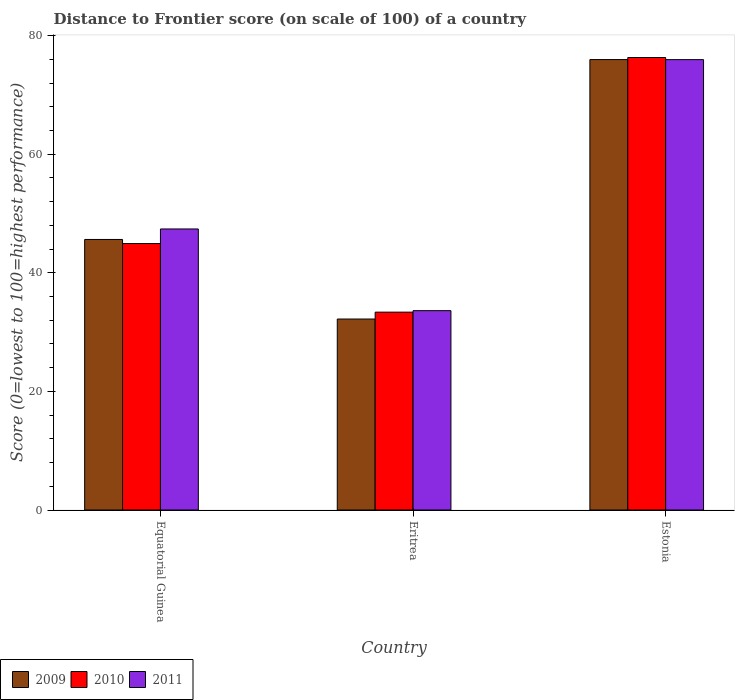How many different coloured bars are there?
Provide a short and direct response. 3. Are the number of bars per tick equal to the number of legend labels?
Make the answer very short. Yes. How many bars are there on the 2nd tick from the left?
Make the answer very short. 3. What is the label of the 2nd group of bars from the left?
Your response must be concise. Eritrea. In how many cases, is the number of bars for a given country not equal to the number of legend labels?
Your response must be concise. 0. What is the distance to frontier score of in 2009 in Estonia?
Your response must be concise. 75.97. Across all countries, what is the maximum distance to frontier score of in 2011?
Give a very brief answer. 75.96. Across all countries, what is the minimum distance to frontier score of in 2011?
Your answer should be very brief. 33.62. In which country was the distance to frontier score of in 2011 maximum?
Provide a short and direct response. Estonia. In which country was the distance to frontier score of in 2011 minimum?
Your answer should be very brief. Eritrea. What is the total distance to frontier score of in 2011 in the graph?
Your response must be concise. 156.98. What is the difference between the distance to frontier score of in 2010 in Equatorial Guinea and that in Eritrea?
Your answer should be compact. 11.57. What is the difference between the distance to frontier score of in 2009 in Estonia and the distance to frontier score of in 2010 in Equatorial Guinea?
Make the answer very short. 31.03. What is the average distance to frontier score of in 2011 per country?
Ensure brevity in your answer.  52.33. What is the difference between the distance to frontier score of of/in 2011 and distance to frontier score of of/in 2009 in Estonia?
Your answer should be very brief. -0.01. In how many countries, is the distance to frontier score of in 2010 greater than 12?
Your response must be concise. 3. What is the ratio of the distance to frontier score of in 2011 in Equatorial Guinea to that in Eritrea?
Give a very brief answer. 1.41. What is the difference between the highest and the second highest distance to frontier score of in 2009?
Provide a succinct answer. -43.76. What is the difference between the highest and the lowest distance to frontier score of in 2011?
Your answer should be very brief. 42.34. What does the 2nd bar from the right in Estonia represents?
Your answer should be compact. 2010. How many bars are there?
Your answer should be compact. 9. Are all the bars in the graph horizontal?
Make the answer very short. No. What is the difference between two consecutive major ticks on the Y-axis?
Your answer should be compact. 20. Does the graph contain any zero values?
Your answer should be compact. No. Does the graph contain grids?
Ensure brevity in your answer.  No. How many legend labels are there?
Give a very brief answer. 3. What is the title of the graph?
Ensure brevity in your answer.  Distance to Frontier score (on scale of 100) of a country. Does "1998" appear as one of the legend labels in the graph?
Give a very brief answer. No. What is the label or title of the X-axis?
Make the answer very short. Country. What is the label or title of the Y-axis?
Your answer should be very brief. Score (0=lowest to 100=highest performance). What is the Score (0=lowest to 100=highest performance) in 2009 in Equatorial Guinea?
Your answer should be compact. 45.63. What is the Score (0=lowest to 100=highest performance) in 2010 in Equatorial Guinea?
Ensure brevity in your answer.  44.94. What is the Score (0=lowest to 100=highest performance) in 2011 in Equatorial Guinea?
Offer a very short reply. 47.4. What is the Score (0=lowest to 100=highest performance) of 2009 in Eritrea?
Provide a succinct answer. 32.21. What is the Score (0=lowest to 100=highest performance) of 2010 in Eritrea?
Keep it short and to the point. 33.37. What is the Score (0=lowest to 100=highest performance) in 2011 in Eritrea?
Give a very brief answer. 33.62. What is the Score (0=lowest to 100=highest performance) of 2009 in Estonia?
Your response must be concise. 75.97. What is the Score (0=lowest to 100=highest performance) of 2010 in Estonia?
Provide a short and direct response. 76.32. What is the Score (0=lowest to 100=highest performance) in 2011 in Estonia?
Your answer should be compact. 75.96. Across all countries, what is the maximum Score (0=lowest to 100=highest performance) in 2009?
Provide a short and direct response. 75.97. Across all countries, what is the maximum Score (0=lowest to 100=highest performance) of 2010?
Offer a terse response. 76.32. Across all countries, what is the maximum Score (0=lowest to 100=highest performance) in 2011?
Provide a short and direct response. 75.96. Across all countries, what is the minimum Score (0=lowest to 100=highest performance) of 2009?
Your answer should be very brief. 32.21. Across all countries, what is the minimum Score (0=lowest to 100=highest performance) in 2010?
Give a very brief answer. 33.37. Across all countries, what is the minimum Score (0=lowest to 100=highest performance) of 2011?
Your response must be concise. 33.62. What is the total Score (0=lowest to 100=highest performance) in 2009 in the graph?
Give a very brief answer. 153.81. What is the total Score (0=lowest to 100=highest performance) of 2010 in the graph?
Your response must be concise. 154.63. What is the total Score (0=lowest to 100=highest performance) of 2011 in the graph?
Your answer should be compact. 156.98. What is the difference between the Score (0=lowest to 100=highest performance) of 2009 in Equatorial Guinea and that in Eritrea?
Provide a succinct answer. 13.42. What is the difference between the Score (0=lowest to 100=highest performance) in 2010 in Equatorial Guinea and that in Eritrea?
Your answer should be very brief. 11.57. What is the difference between the Score (0=lowest to 100=highest performance) in 2011 in Equatorial Guinea and that in Eritrea?
Offer a very short reply. 13.78. What is the difference between the Score (0=lowest to 100=highest performance) in 2009 in Equatorial Guinea and that in Estonia?
Provide a short and direct response. -30.34. What is the difference between the Score (0=lowest to 100=highest performance) of 2010 in Equatorial Guinea and that in Estonia?
Offer a terse response. -31.38. What is the difference between the Score (0=lowest to 100=highest performance) in 2011 in Equatorial Guinea and that in Estonia?
Your answer should be compact. -28.56. What is the difference between the Score (0=lowest to 100=highest performance) in 2009 in Eritrea and that in Estonia?
Offer a very short reply. -43.76. What is the difference between the Score (0=lowest to 100=highest performance) in 2010 in Eritrea and that in Estonia?
Provide a succinct answer. -42.95. What is the difference between the Score (0=lowest to 100=highest performance) of 2011 in Eritrea and that in Estonia?
Your response must be concise. -42.34. What is the difference between the Score (0=lowest to 100=highest performance) of 2009 in Equatorial Guinea and the Score (0=lowest to 100=highest performance) of 2010 in Eritrea?
Your response must be concise. 12.26. What is the difference between the Score (0=lowest to 100=highest performance) of 2009 in Equatorial Guinea and the Score (0=lowest to 100=highest performance) of 2011 in Eritrea?
Your response must be concise. 12.01. What is the difference between the Score (0=lowest to 100=highest performance) in 2010 in Equatorial Guinea and the Score (0=lowest to 100=highest performance) in 2011 in Eritrea?
Your answer should be very brief. 11.32. What is the difference between the Score (0=lowest to 100=highest performance) of 2009 in Equatorial Guinea and the Score (0=lowest to 100=highest performance) of 2010 in Estonia?
Provide a succinct answer. -30.69. What is the difference between the Score (0=lowest to 100=highest performance) in 2009 in Equatorial Guinea and the Score (0=lowest to 100=highest performance) in 2011 in Estonia?
Ensure brevity in your answer.  -30.33. What is the difference between the Score (0=lowest to 100=highest performance) in 2010 in Equatorial Guinea and the Score (0=lowest to 100=highest performance) in 2011 in Estonia?
Make the answer very short. -31.02. What is the difference between the Score (0=lowest to 100=highest performance) in 2009 in Eritrea and the Score (0=lowest to 100=highest performance) in 2010 in Estonia?
Offer a very short reply. -44.11. What is the difference between the Score (0=lowest to 100=highest performance) in 2009 in Eritrea and the Score (0=lowest to 100=highest performance) in 2011 in Estonia?
Your answer should be compact. -43.75. What is the difference between the Score (0=lowest to 100=highest performance) of 2010 in Eritrea and the Score (0=lowest to 100=highest performance) of 2011 in Estonia?
Offer a terse response. -42.59. What is the average Score (0=lowest to 100=highest performance) in 2009 per country?
Make the answer very short. 51.27. What is the average Score (0=lowest to 100=highest performance) in 2010 per country?
Your answer should be very brief. 51.54. What is the average Score (0=lowest to 100=highest performance) of 2011 per country?
Provide a succinct answer. 52.33. What is the difference between the Score (0=lowest to 100=highest performance) of 2009 and Score (0=lowest to 100=highest performance) of 2010 in Equatorial Guinea?
Your response must be concise. 0.69. What is the difference between the Score (0=lowest to 100=highest performance) in 2009 and Score (0=lowest to 100=highest performance) in 2011 in Equatorial Guinea?
Keep it short and to the point. -1.77. What is the difference between the Score (0=lowest to 100=highest performance) in 2010 and Score (0=lowest to 100=highest performance) in 2011 in Equatorial Guinea?
Keep it short and to the point. -2.46. What is the difference between the Score (0=lowest to 100=highest performance) of 2009 and Score (0=lowest to 100=highest performance) of 2010 in Eritrea?
Your answer should be compact. -1.16. What is the difference between the Score (0=lowest to 100=highest performance) of 2009 and Score (0=lowest to 100=highest performance) of 2011 in Eritrea?
Offer a terse response. -1.41. What is the difference between the Score (0=lowest to 100=highest performance) of 2010 and Score (0=lowest to 100=highest performance) of 2011 in Eritrea?
Offer a terse response. -0.25. What is the difference between the Score (0=lowest to 100=highest performance) of 2009 and Score (0=lowest to 100=highest performance) of 2010 in Estonia?
Your response must be concise. -0.35. What is the difference between the Score (0=lowest to 100=highest performance) in 2009 and Score (0=lowest to 100=highest performance) in 2011 in Estonia?
Offer a terse response. 0.01. What is the difference between the Score (0=lowest to 100=highest performance) of 2010 and Score (0=lowest to 100=highest performance) of 2011 in Estonia?
Make the answer very short. 0.36. What is the ratio of the Score (0=lowest to 100=highest performance) of 2009 in Equatorial Guinea to that in Eritrea?
Offer a terse response. 1.42. What is the ratio of the Score (0=lowest to 100=highest performance) in 2010 in Equatorial Guinea to that in Eritrea?
Make the answer very short. 1.35. What is the ratio of the Score (0=lowest to 100=highest performance) in 2011 in Equatorial Guinea to that in Eritrea?
Make the answer very short. 1.41. What is the ratio of the Score (0=lowest to 100=highest performance) in 2009 in Equatorial Guinea to that in Estonia?
Make the answer very short. 0.6. What is the ratio of the Score (0=lowest to 100=highest performance) of 2010 in Equatorial Guinea to that in Estonia?
Offer a very short reply. 0.59. What is the ratio of the Score (0=lowest to 100=highest performance) of 2011 in Equatorial Guinea to that in Estonia?
Offer a very short reply. 0.62. What is the ratio of the Score (0=lowest to 100=highest performance) of 2009 in Eritrea to that in Estonia?
Provide a succinct answer. 0.42. What is the ratio of the Score (0=lowest to 100=highest performance) in 2010 in Eritrea to that in Estonia?
Make the answer very short. 0.44. What is the ratio of the Score (0=lowest to 100=highest performance) of 2011 in Eritrea to that in Estonia?
Your answer should be very brief. 0.44. What is the difference between the highest and the second highest Score (0=lowest to 100=highest performance) in 2009?
Give a very brief answer. 30.34. What is the difference between the highest and the second highest Score (0=lowest to 100=highest performance) of 2010?
Offer a terse response. 31.38. What is the difference between the highest and the second highest Score (0=lowest to 100=highest performance) of 2011?
Your answer should be compact. 28.56. What is the difference between the highest and the lowest Score (0=lowest to 100=highest performance) of 2009?
Your answer should be compact. 43.76. What is the difference between the highest and the lowest Score (0=lowest to 100=highest performance) in 2010?
Offer a terse response. 42.95. What is the difference between the highest and the lowest Score (0=lowest to 100=highest performance) in 2011?
Provide a short and direct response. 42.34. 